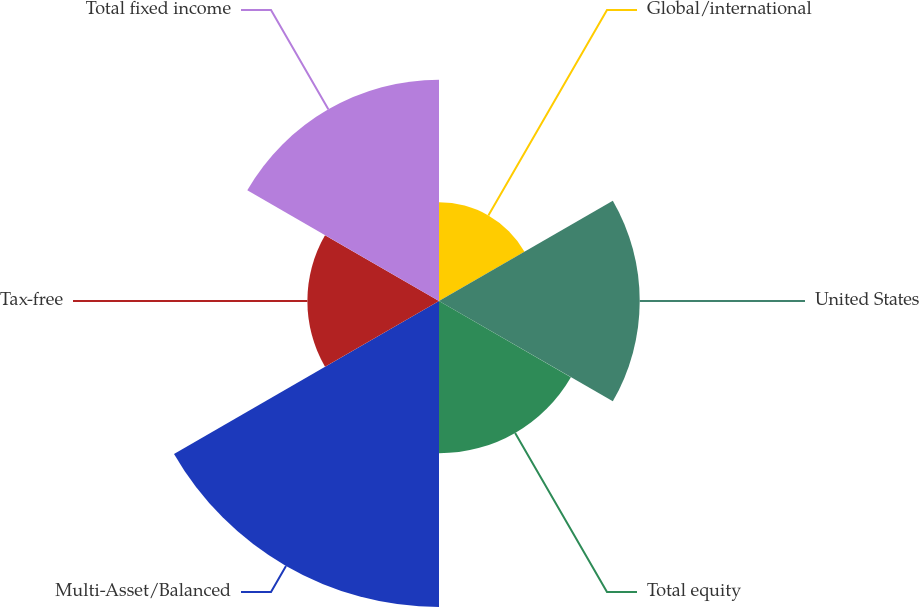Convert chart to OTSL. <chart><loc_0><loc_0><loc_500><loc_500><pie_chart><fcel>Global/international<fcel>United States<fcel>Total equity<fcel>Multi-Asset/Balanced<fcel>Tax-free<fcel>Total fixed income<nl><fcel>8.89%<fcel>18.07%<fcel>13.71%<fcel>27.55%<fcel>11.85%<fcel>19.93%<nl></chart> 